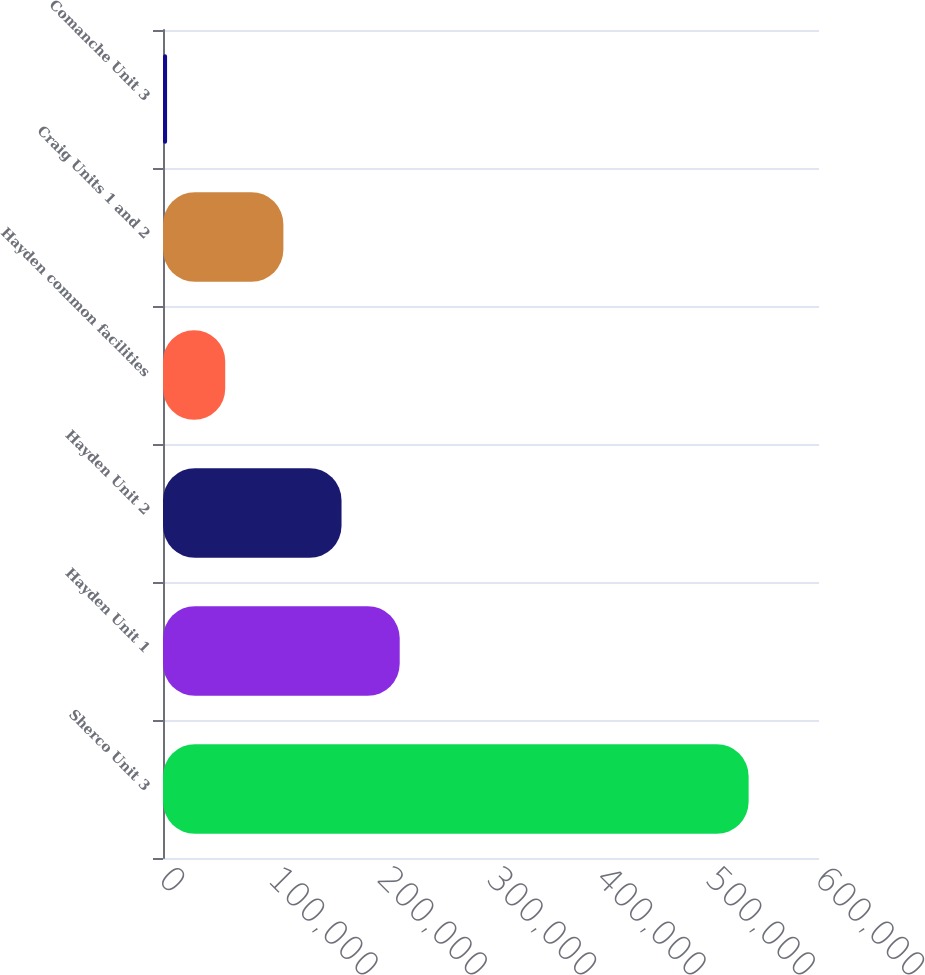Convert chart to OTSL. <chart><loc_0><loc_0><loc_500><loc_500><bar_chart><fcel>Sherco Unit 3<fcel>Hayden Unit 1<fcel>Hayden Unit 2<fcel>Hayden common facilities<fcel>Craig Units 1 and 2<fcel>Comanche Unit 3<nl><fcel>535643<fcel>216490<fcel>163298<fcel>56913.2<fcel>110105<fcel>3721<nl></chart> 